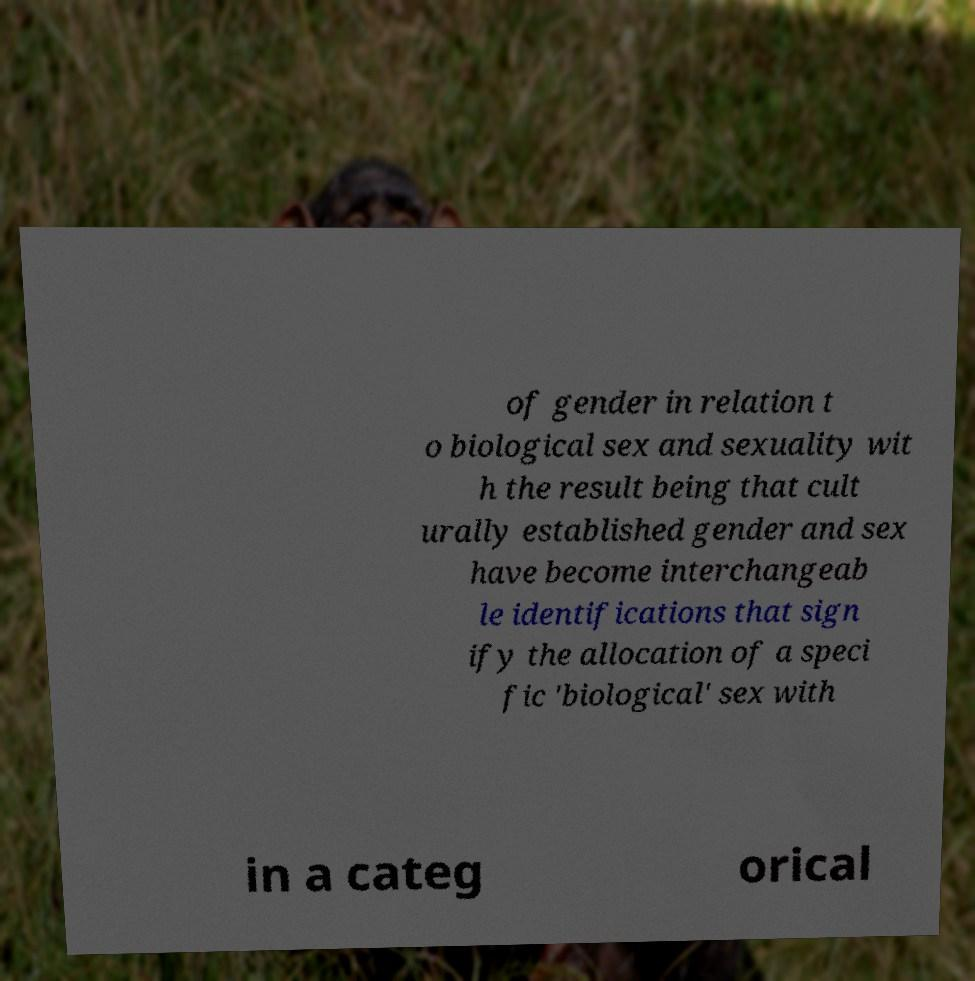Could you assist in decoding the text presented in this image and type it out clearly? of gender in relation t o biological sex and sexuality wit h the result being that cult urally established gender and sex have become interchangeab le identifications that sign ify the allocation of a speci fic 'biological' sex with in a categ orical 